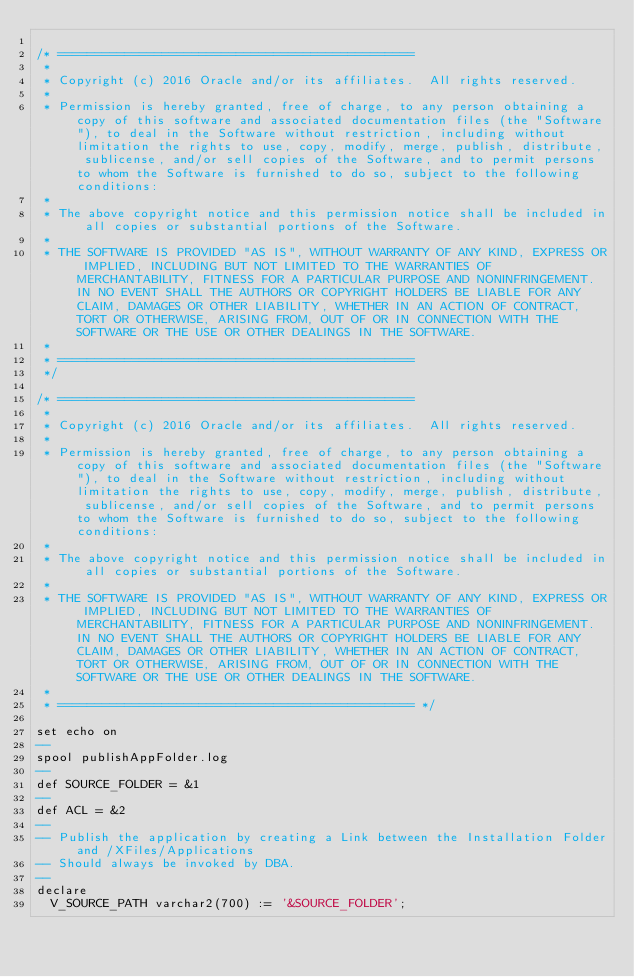Convert code to text. <code><loc_0><loc_0><loc_500><loc_500><_SQL_>
/* ================================================  
 *    
 * Copyright (c) 2016 Oracle and/or its affiliates.  All rights reserved.
 *
 * Permission is hereby granted, free of charge, to any person obtaining a copy of this software and associated documentation files (the "Software"), to deal in the Software without restriction, including without limitation the rights to use, copy, modify, merge, publish, distribute, sublicense, and/or sell copies of the Software, and to permit persons to whom the Software is furnished to do so, subject to the following conditions:
 *
 * The above copyright notice and this permission notice shall be included in all copies or substantial portions of the Software.
 *
 * THE SOFTWARE IS PROVIDED "AS IS", WITHOUT WARRANTY OF ANY KIND, EXPRESS OR IMPLIED, INCLUDING BUT NOT LIMITED TO THE WARRANTIES OF MERCHANTABILITY, FITNESS FOR A PARTICULAR PURPOSE AND NONINFRINGEMENT. IN NO EVENT SHALL THE AUTHORS OR COPYRIGHT HOLDERS BE LIABLE FOR ANY CLAIM, DAMAGES OR OTHER LIABILITY, WHETHER IN AN ACTION OF CONTRACT, TORT OR OTHERWISE, ARISING FROM, OUT OF OR IN CONNECTION WITH THE SOFTWARE OR THE USE OR OTHER DEALINGS IN THE SOFTWARE.
 *
 * ================================================ 
 */

/* ================================================  
 *    
 * Copyright (c) 2016 Oracle and/or its affiliates.  All rights reserved.
 *
 * Permission is hereby granted, free of charge, to any person obtaining a copy of this software and associated documentation files (the "Software"), to deal in the Software without restriction, including without limitation the rights to use, copy, modify, merge, publish, distribute, sublicense, and/or sell copies of the Software, and to permit persons to whom the Software is furnished to do so, subject to the following conditions:
 *
 * The above copyright notice and this permission notice shall be included in all copies or substantial portions of the Software.
 *
 * THE SOFTWARE IS PROVIDED "AS IS", WITHOUT WARRANTY OF ANY KIND, EXPRESS OR IMPLIED, INCLUDING BUT NOT LIMITED TO THE WARRANTIES OF MERCHANTABILITY, FITNESS FOR A PARTICULAR PURPOSE AND NONINFRINGEMENT. IN NO EVENT SHALL THE AUTHORS OR COPYRIGHT HOLDERS BE LIABLE FOR ANY CLAIM, DAMAGES OR OTHER LIABILITY, WHETHER IN AN ACTION OF CONTRACT, TORT OR OTHERWISE, ARISING FROM, OUT OF OR IN CONNECTION WITH THE SOFTWARE OR THE USE OR OTHER DEALINGS IN THE SOFTWARE.
 *
 * ================================================ */

set echo on
--
spool publishAppFolder.log
--
def SOURCE_FOLDER = &1
--
def ACL = &2
--
-- Publish the application by creating a Link between the Installation Folder and /XFiles/Applications
-- Should always be invoked by DBA.
--
declare
  V_SOURCE_PATH varchar2(700) := '&SOURCE_FOLDER';</code> 